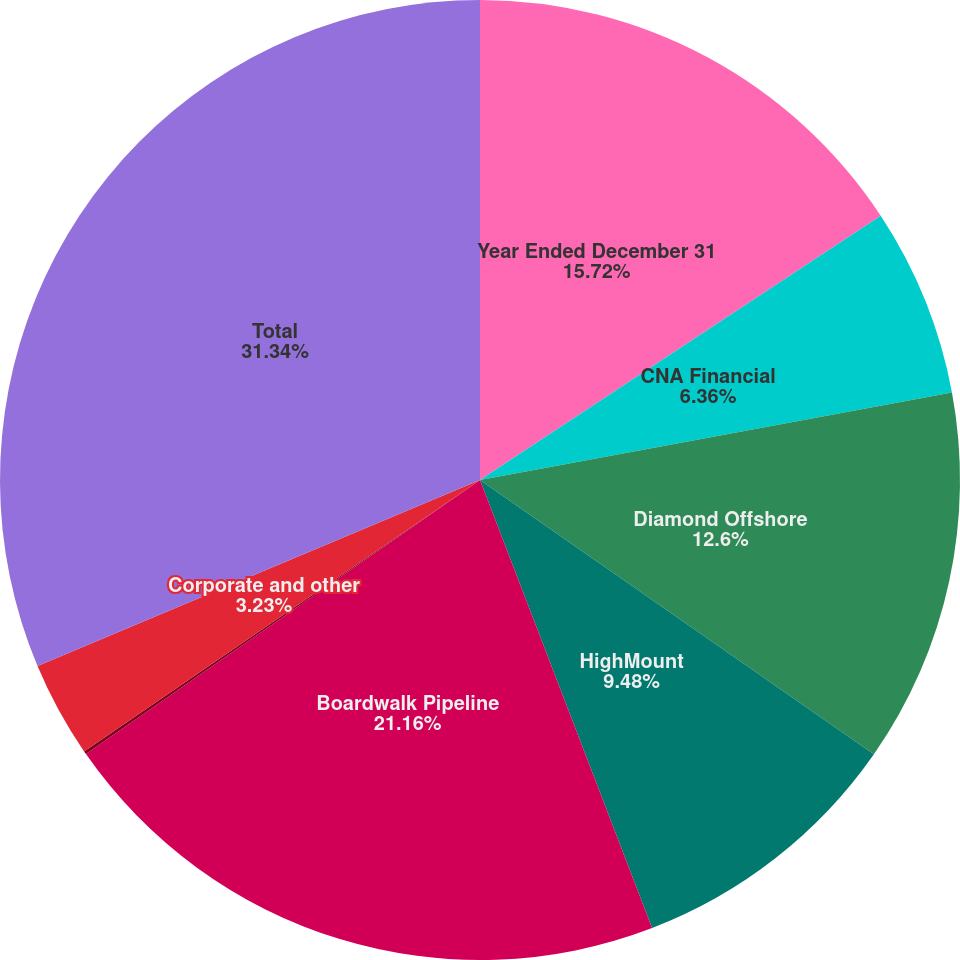Convert chart. <chart><loc_0><loc_0><loc_500><loc_500><pie_chart><fcel>Year Ended December 31<fcel>CNA Financial<fcel>Diamond Offshore<fcel>HighMount<fcel>Boardwalk Pipeline<fcel>Loews Hotels<fcel>Corporate and other<fcel>Total<nl><fcel>15.72%<fcel>6.36%<fcel>12.6%<fcel>9.48%<fcel>21.16%<fcel>0.11%<fcel>3.23%<fcel>31.33%<nl></chart> 